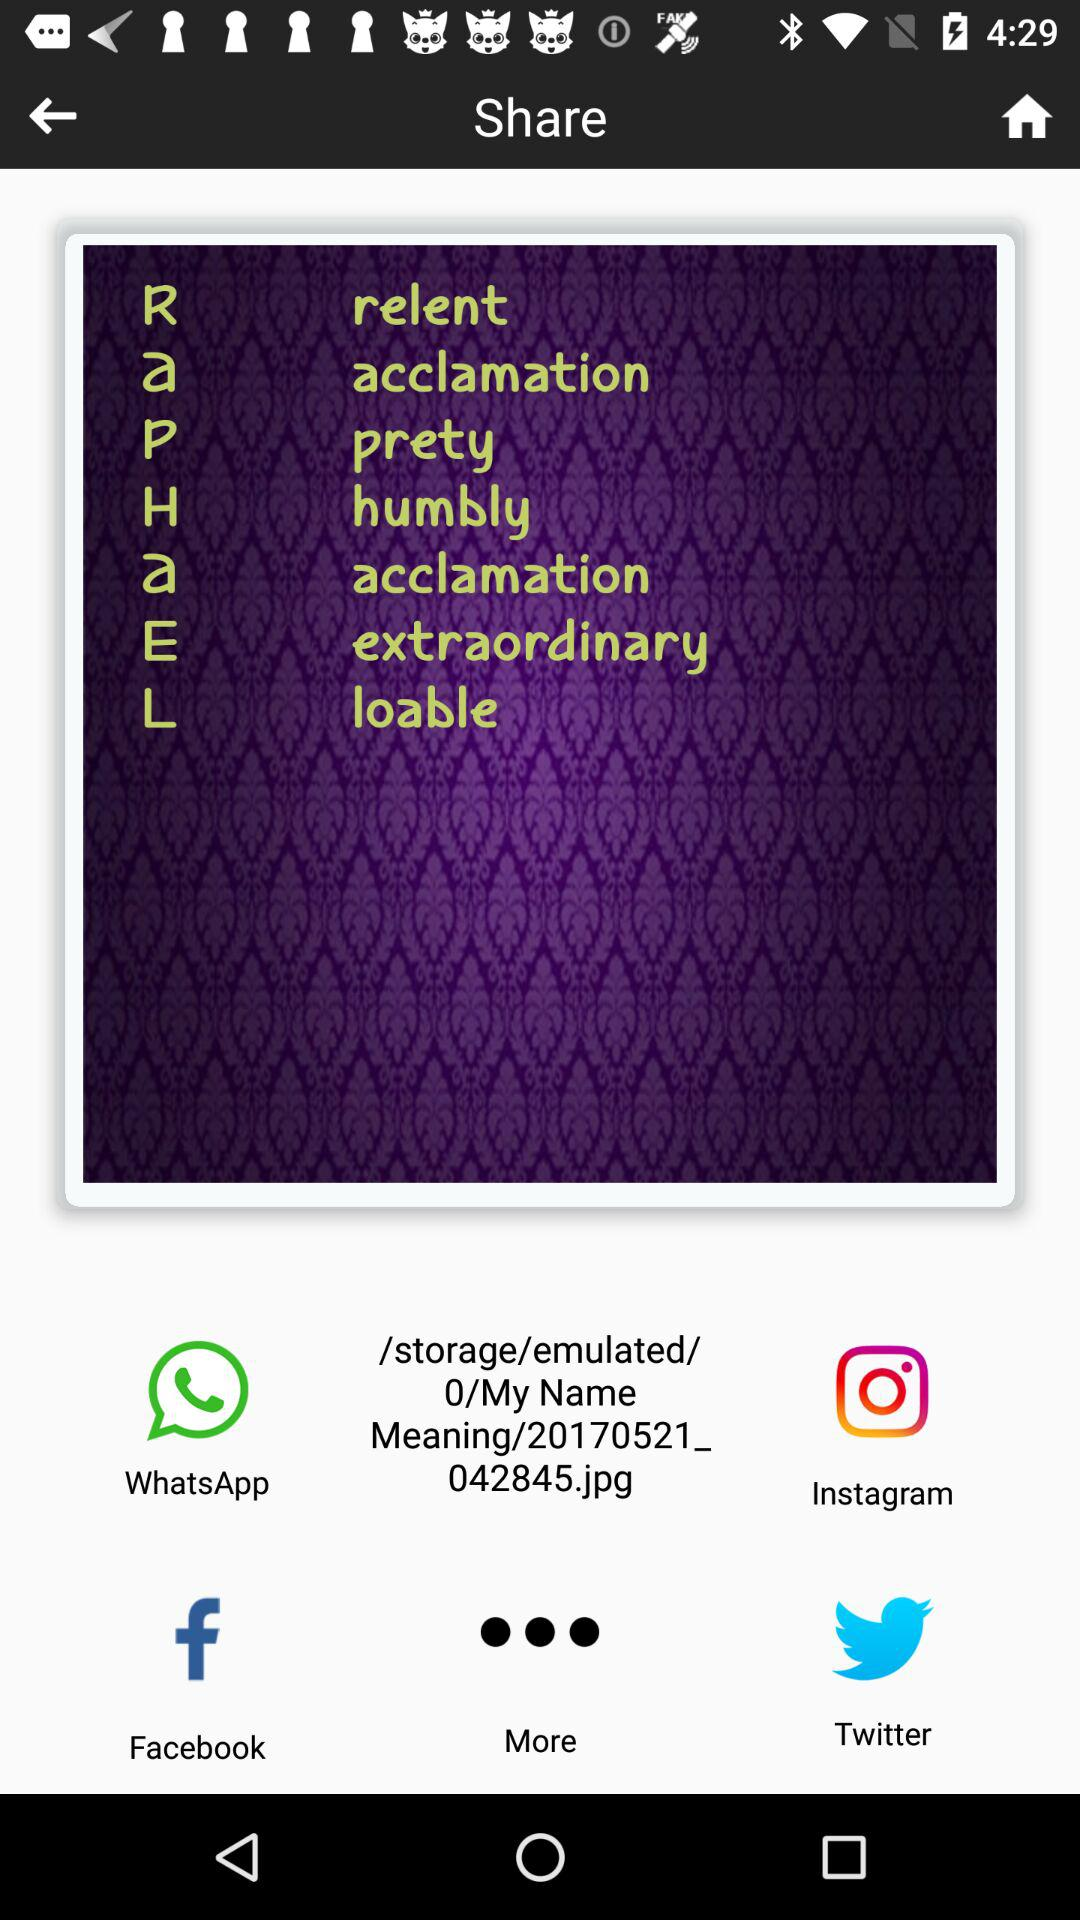Through which applications can the image be shared? The image can be shared through "WhatsApp", "Instagram", "Facebook" and "Twitter". 